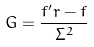Convert formula to latex. <formula><loc_0><loc_0><loc_500><loc_500>G = \frac { f ^ { \prime } r - f } { \Sigma ^ { 2 } }</formula> 